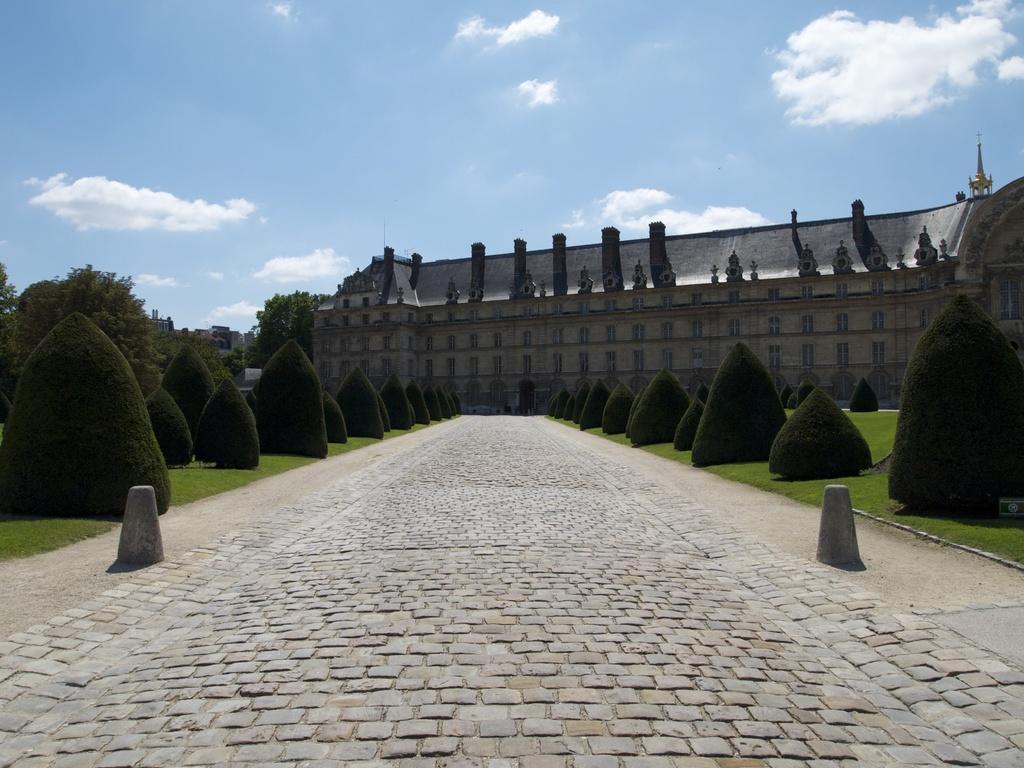Describe this image in one or two sentences. In this image we can see a building, plants, grass, trees and cloudy sky.  